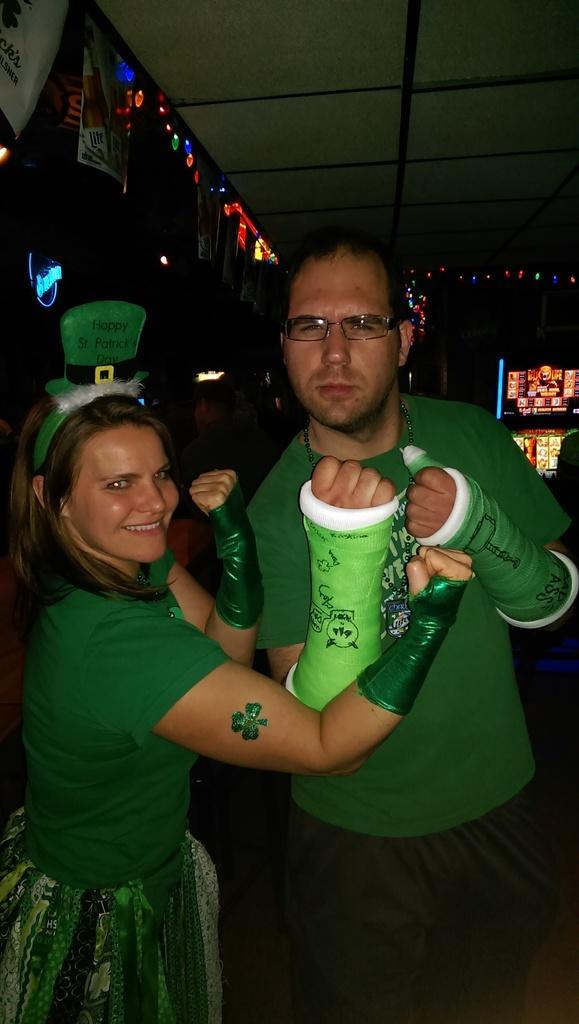Describe this image in one or two sentences. This image consists of a man and a woman. Both are wearing green dresses. In the background, we can see the posters on the wall and lights. At the top, there is a roof. 